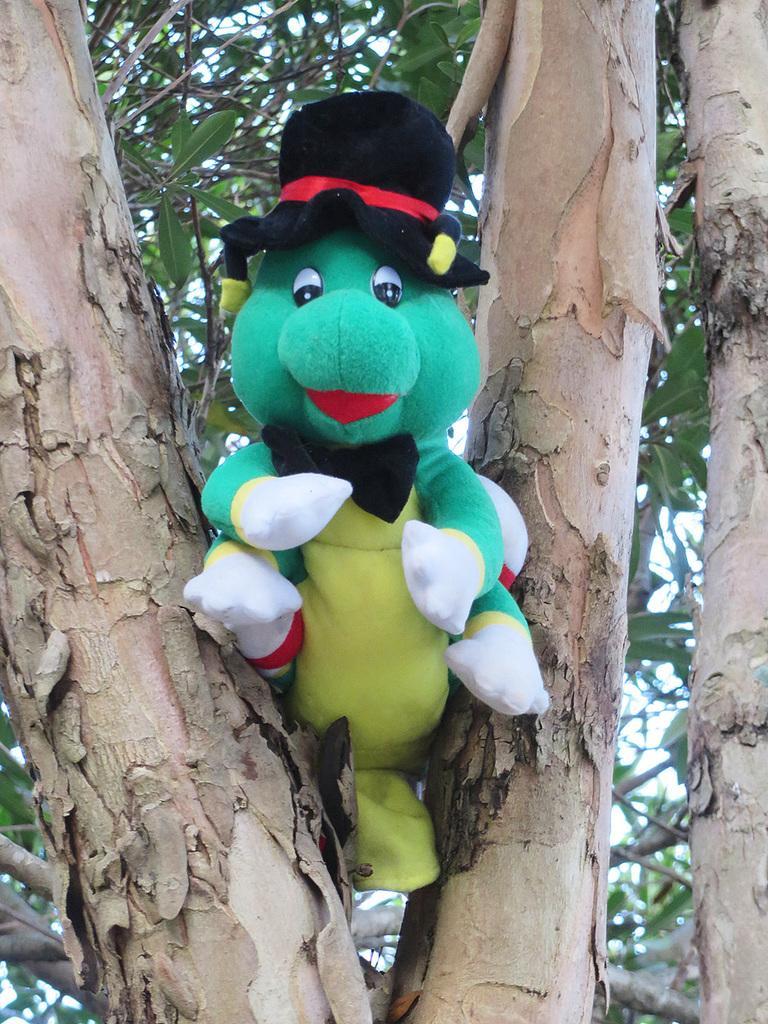How would you summarize this image in a sentence or two? In this image I can see the doll which is colorful. It is on the tree. In the background I can see the sky. 